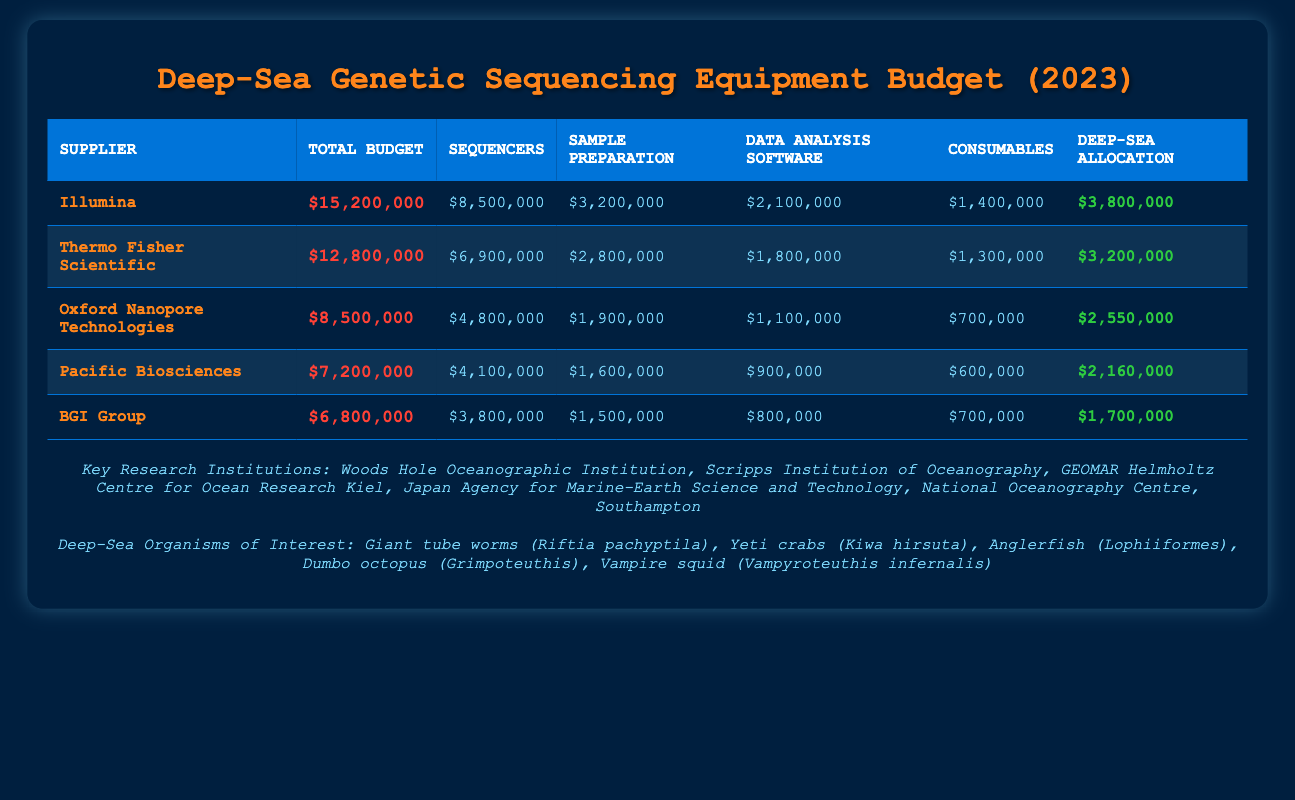What is the total annual budget of Illumina? The annual budget for Illumina is listed directly in the table under "Total Budget," which reads $15,200,000.
Answer: $15,200,000 Which supplier has the highest allocation for deep-sea specific projects? To answer this, we look at the "Deep-Sea Allocation" column for each supplier and see which number is the largest. Illumina has $3,800,000, which is higher than any other supplier's allocation.
Answer: Illumina What is the combined total budget for the two highest-budget suppliers? The total budget for the highest budget supplier, Illumina, is $15,200,000, and for the second highest, Thermo Fisher Scientific, it's $12,800,000. Adding these two amounts yields $15,200,000 + $12,800,000 = $28,000,000.
Answer: $28,000,000 Is the budget for consumables for Oxford Nanopore Technologies greater than that of BGI Group? We need to compare the "Consumables" values for both suppliers. Oxford Nanopore Technologies has $700,000 while BGI Group has a higher amount of $700,000. This shows they are equal, meaning the answer is false.
Answer: No What is the average budget allocation for sample preparation across all suppliers? The sample preparation budgets are: Illumina - $3,200,000, Thermo Fisher Scientific - $2,800,000, Oxford Nanopore Technologies - $1,900,000, Pacific Biosciences - $1,600,000, and BGI Group - $1,500,000. Adding them yields $11,000,000, and there are 5 suppliers, so the average is $11,000,000 / 5 = $2,200,000.
Answer: $2,200,000 Which supplier has the lowest budget for sequencers, and what is that amount? We compare the "Sequencers" values from each supplier. The lowest is BGI Group with $3,800,000. Thus, the answer is BGI Group with $3,800,000.
Answer: BGI Group with $3,800,000 What percentage of the total budget does Thermo Fisher Scientific allocate to data analysis software? Thermo Fisher Scientific has an annual budget of $12,800,000, with $1,800,000 allocated to data analysis software. To find the percentage, divide $1,800,000 by $12,800,000 and then multiply by 100, yielding approximately 14.06%.
Answer: 14.06% Is the total budget for Pacific Biosciences greater than $7 million? Checking the "Total Budget" for Pacific Biosciences shows $7,200,000, which is indeed greater than $7 million. Hence, the answer is yes.
Answer: Yes How much more does Illumina spend on sequencers compared to Pacific Biosciences? To find this, we subtract Pacific Biosciences' sequencer budget ($4,100,000) from Illumina's ($8,500,000). Therefore, $8,500,000 - $4,100,000 = $4,400,000.
Answer: $4,400,000 